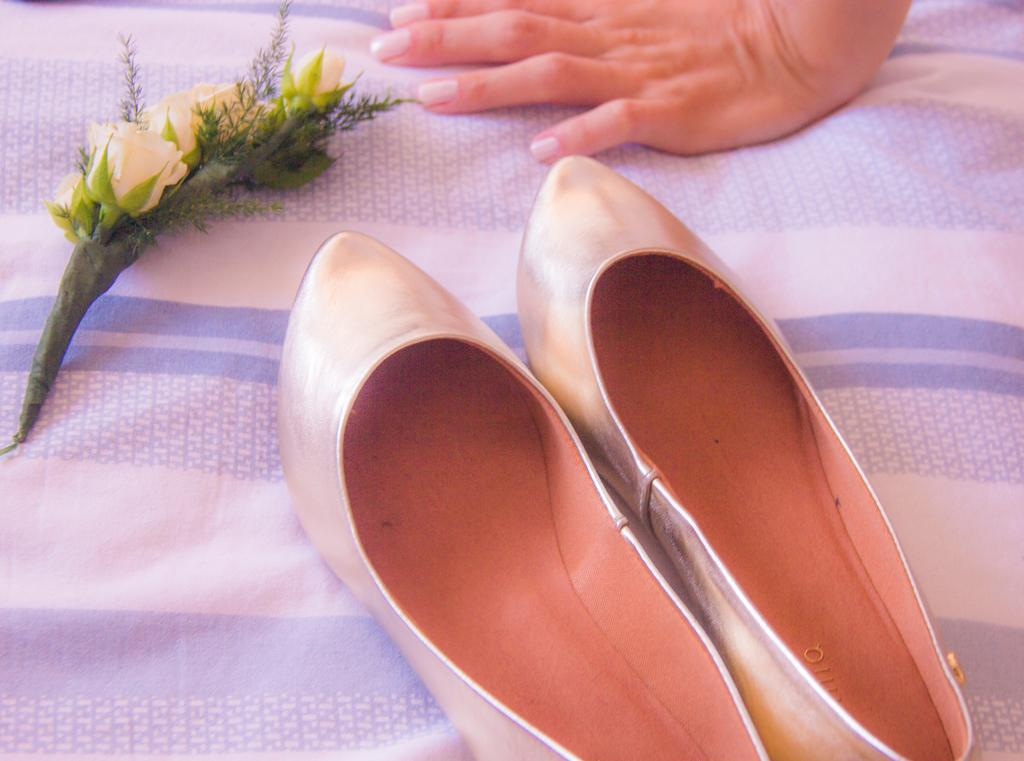What type of material is present in the image? There is cloth in the image. What type of accessory can be seen in the image? There is a pair of footwear in the image. What type of natural element is present in the image? There are flowers in the image. Can you identify any body part of a person in the image? A hand of a person is visible in the image. How many ducks are present in the image? There are no ducks present in the image. What type of snake can be seen slithering on the cloth in the image? There is no snake present in the image. 